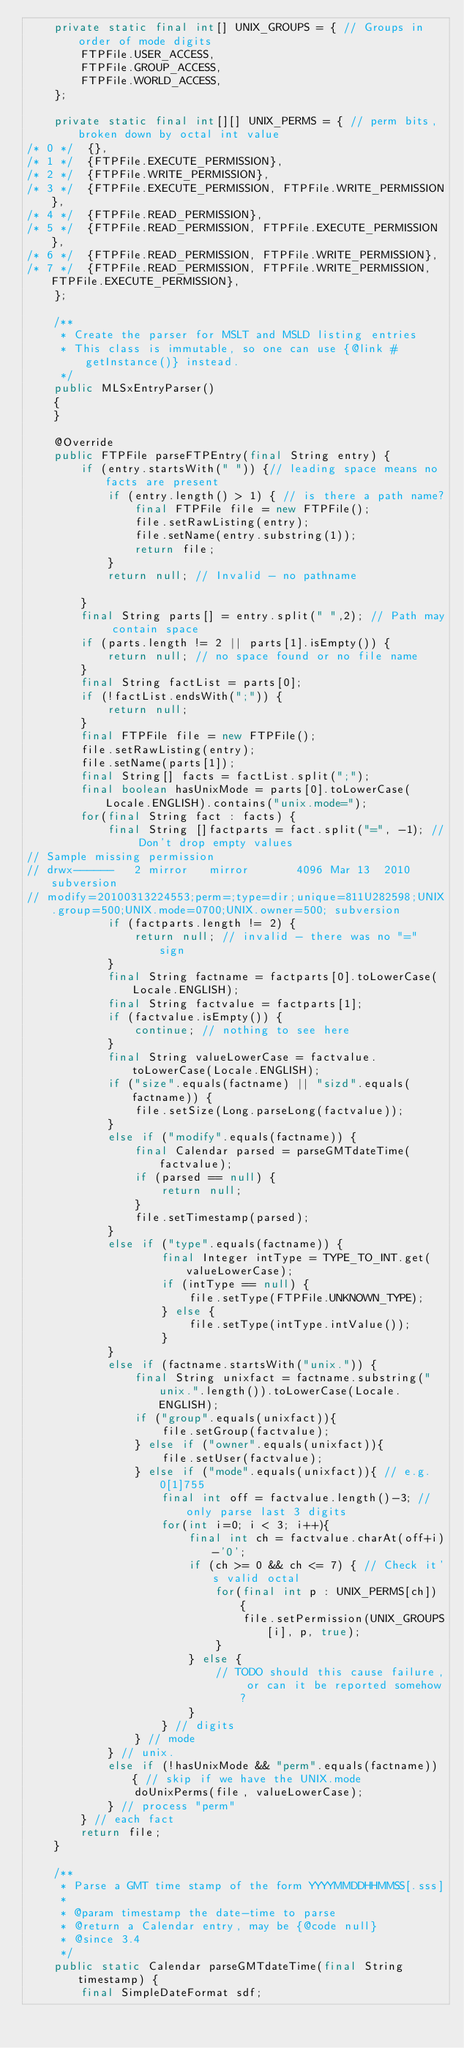Convert code to text. <code><loc_0><loc_0><loc_500><loc_500><_Java_>    private static final int[] UNIX_GROUPS = { // Groups in order of mode digits
        FTPFile.USER_ACCESS,
        FTPFile.GROUP_ACCESS,
        FTPFile.WORLD_ACCESS,
    };

    private static final int[][] UNIX_PERMS = { // perm bits, broken down by octal int value
/* 0 */  {},
/* 1 */  {FTPFile.EXECUTE_PERMISSION},
/* 2 */  {FTPFile.WRITE_PERMISSION},
/* 3 */  {FTPFile.EXECUTE_PERMISSION, FTPFile.WRITE_PERMISSION},
/* 4 */  {FTPFile.READ_PERMISSION},
/* 5 */  {FTPFile.READ_PERMISSION, FTPFile.EXECUTE_PERMISSION},
/* 6 */  {FTPFile.READ_PERMISSION, FTPFile.WRITE_PERMISSION},
/* 7 */  {FTPFile.READ_PERMISSION, FTPFile.WRITE_PERMISSION, FTPFile.EXECUTE_PERMISSION},
    };

    /**
     * Create the parser for MSLT and MSLD listing entries
     * This class is immutable, so one can use {@link #getInstance()} instead.
     */
    public MLSxEntryParser()
    {
    }

    @Override
    public FTPFile parseFTPEntry(final String entry) {
        if (entry.startsWith(" ")) {// leading space means no facts are present
            if (entry.length() > 1) { // is there a path name?
                final FTPFile file = new FTPFile();
                file.setRawListing(entry);
                file.setName(entry.substring(1));
                return file;
            }
            return null; // Invalid - no pathname

        }
        final String parts[] = entry.split(" ",2); // Path may contain space
        if (parts.length != 2 || parts[1].isEmpty()) {
            return null; // no space found or no file name
        }
        final String factList = parts[0];
        if (!factList.endsWith(";")) {
            return null;
        }
        final FTPFile file = new FTPFile();
        file.setRawListing(entry);
        file.setName(parts[1]);
        final String[] facts = factList.split(";");
        final boolean hasUnixMode = parts[0].toLowerCase(Locale.ENGLISH).contains("unix.mode=");
        for(final String fact : facts) {
            final String []factparts = fact.split("=", -1); // Don't drop empty values
// Sample missing permission
// drwx------   2 mirror   mirror       4096 Mar 13  2010 subversion
// modify=20100313224553;perm=;type=dir;unique=811U282598;UNIX.group=500;UNIX.mode=0700;UNIX.owner=500; subversion
            if (factparts.length != 2) {
                return null; // invalid - there was no "=" sign
            }
            final String factname = factparts[0].toLowerCase(Locale.ENGLISH);
            final String factvalue = factparts[1];
            if (factvalue.isEmpty()) {
                continue; // nothing to see here
            }
            final String valueLowerCase = factvalue.toLowerCase(Locale.ENGLISH);
            if ("size".equals(factname) || "sizd".equals(factname)) {
                file.setSize(Long.parseLong(factvalue));
            }
            else if ("modify".equals(factname)) {
                final Calendar parsed = parseGMTdateTime(factvalue);
                if (parsed == null) {
                    return null;
                }
                file.setTimestamp(parsed);
            }
            else if ("type".equals(factname)) {
                    final Integer intType = TYPE_TO_INT.get(valueLowerCase);
                    if (intType == null) {
                        file.setType(FTPFile.UNKNOWN_TYPE);
                    } else {
                        file.setType(intType.intValue());
                    }
            }
            else if (factname.startsWith("unix.")) {
                final String unixfact = factname.substring("unix.".length()).toLowerCase(Locale.ENGLISH);
                if ("group".equals(unixfact)){
                    file.setGroup(factvalue);
                } else if ("owner".equals(unixfact)){
                    file.setUser(factvalue);
                } else if ("mode".equals(unixfact)){ // e.g. 0[1]755
                    final int off = factvalue.length()-3; // only parse last 3 digits
                    for(int i=0; i < 3; i++){
                        final int ch = factvalue.charAt(off+i)-'0';
                        if (ch >= 0 && ch <= 7) { // Check it's valid octal
                            for(final int p : UNIX_PERMS[ch]) {
                                file.setPermission(UNIX_GROUPS[i], p, true);
                            }
                        } else {
                            // TODO should this cause failure, or can it be reported somehow?
                        }
                    } // digits
                } // mode
            } // unix.
            else if (!hasUnixMode && "perm".equals(factname)) { // skip if we have the UNIX.mode
                doUnixPerms(file, valueLowerCase);
            } // process "perm"
        } // each fact
        return file;
    }

    /**
     * Parse a GMT time stamp of the form YYYYMMDDHHMMSS[.sss]
     *
     * @param timestamp the date-time to parse
     * @return a Calendar entry, may be {@code null}
     * @since 3.4
     */
    public static Calendar parseGMTdateTime(final String timestamp) {
        final SimpleDateFormat sdf;</code> 